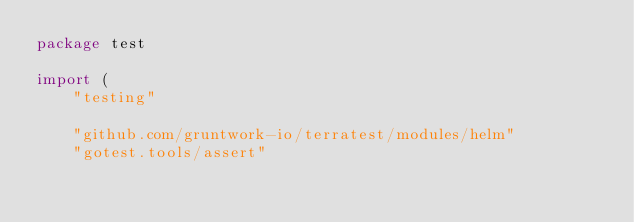Convert code to text. <code><loc_0><loc_0><loc_500><loc_500><_Go_>package test

import (
	"testing"

	"github.com/gruntwork-io/terratest/modules/helm"
	"gotest.tools/assert"</code> 